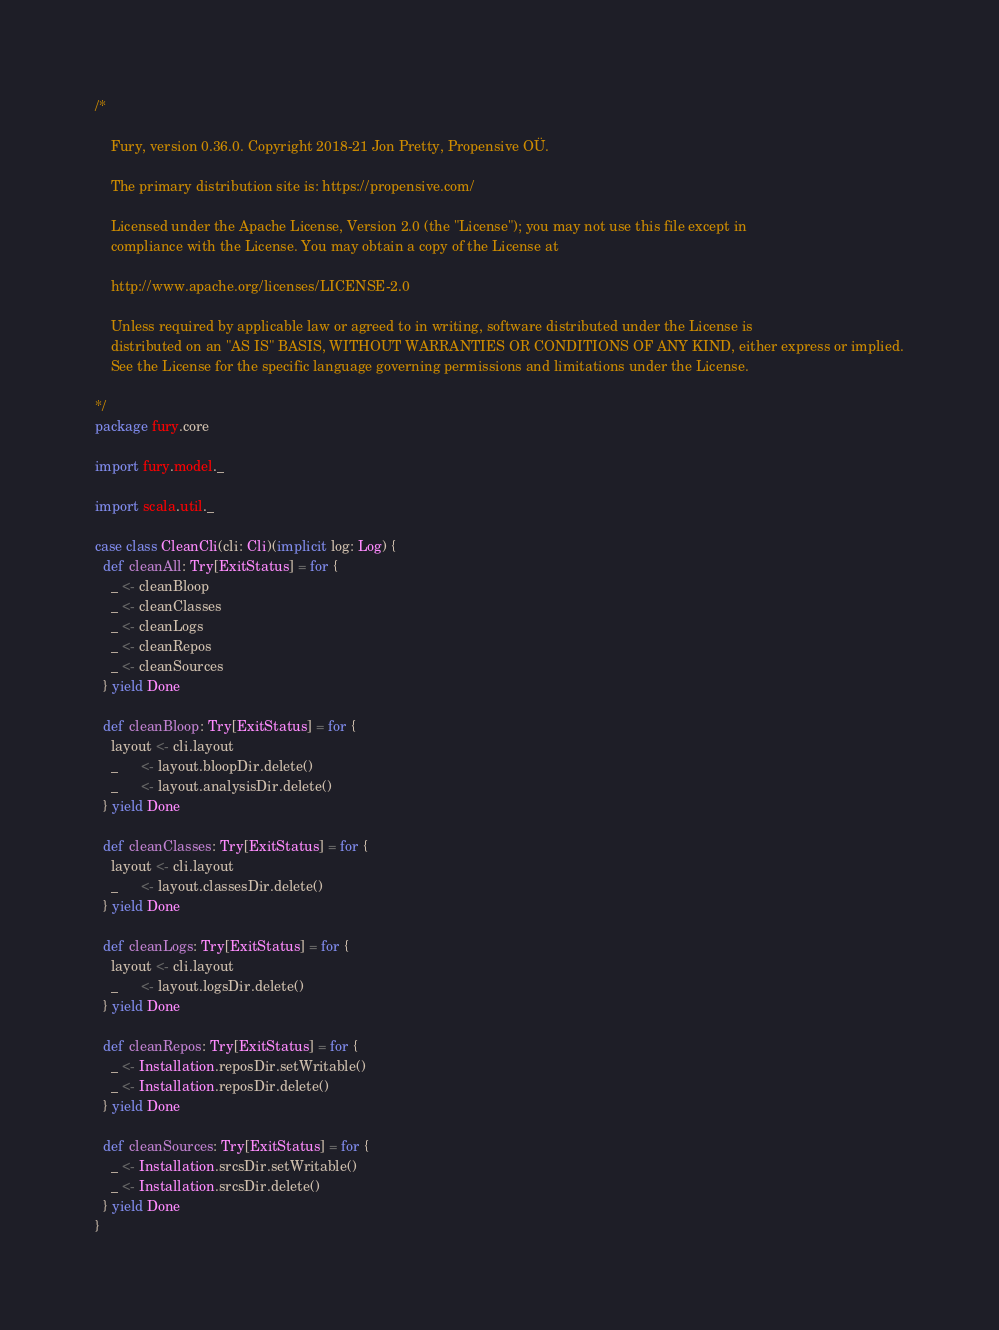Convert code to text. <code><loc_0><loc_0><loc_500><loc_500><_Scala_>/*

    Fury, version 0.36.0. Copyright 2018-21 Jon Pretty, Propensive OÜ.

    The primary distribution site is: https://propensive.com/

    Licensed under the Apache License, Version 2.0 (the "License"); you may not use this file except in
    compliance with the License. You may obtain a copy of the License at

    http://www.apache.org/licenses/LICENSE-2.0

    Unless required by applicable law or agreed to in writing, software distributed under the License is
    distributed on an "AS IS" BASIS, WITHOUT WARRANTIES OR CONDITIONS OF ANY KIND, either express or implied.
    See the License for the specific language governing permissions and limitations under the License.

*/
package fury.core

import fury.model._

import scala.util._

case class CleanCli(cli: Cli)(implicit log: Log) {
  def cleanAll: Try[ExitStatus] = for {
    _ <- cleanBloop
    _ <- cleanClasses
    _ <- cleanLogs
    _ <- cleanRepos
    _ <- cleanSources
  } yield Done

  def cleanBloop: Try[ExitStatus] = for {
    layout <- cli.layout
    _      <- layout.bloopDir.delete()
    _      <- layout.analysisDir.delete()
  } yield Done

  def cleanClasses: Try[ExitStatus] = for {
    layout <- cli.layout
    _      <- layout.classesDir.delete()
  } yield Done

  def cleanLogs: Try[ExitStatus] = for {
    layout <- cli.layout
    _      <- layout.logsDir.delete()
  } yield Done
  
  def cleanRepos: Try[ExitStatus] = for {
    _ <- Installation.reposDir.setWritable()
    _ <- Installation.reposDir.delete()
  } yield Done
  
  def cleanSources: Try[ExitStatus] = for {
    _ <- Installation.srcsDir.setWritable()
    _ <- Installation.srcsDir.delete()
  } yield Done
}
</code> 